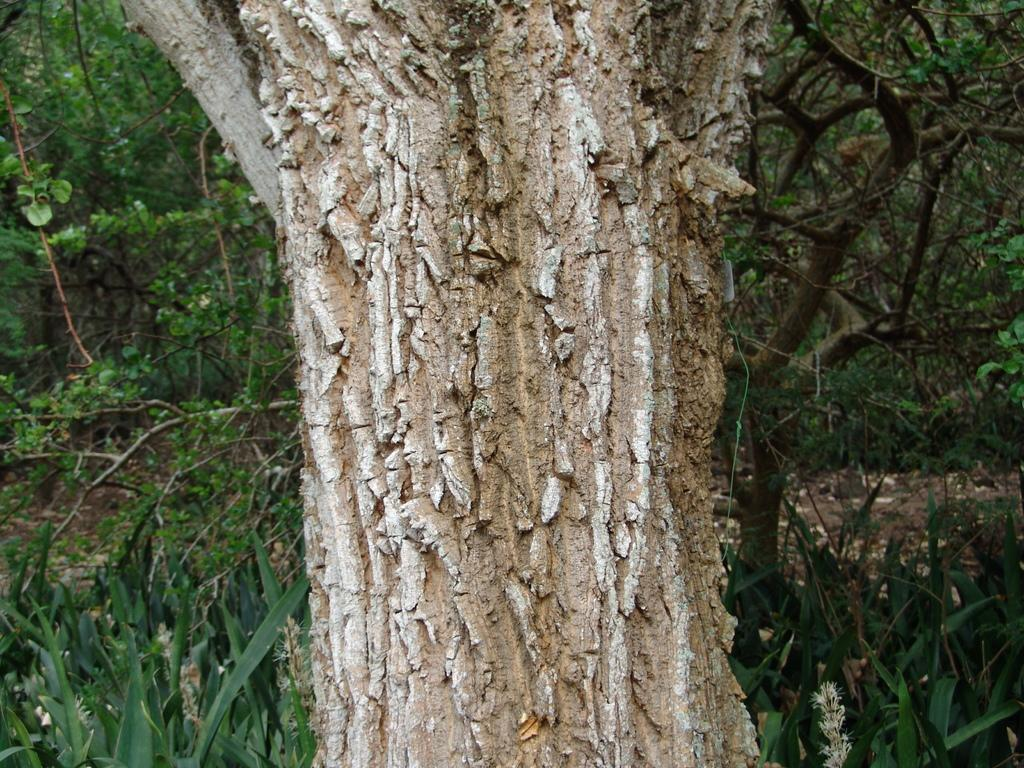What is the main object in the image? There is a branch of a tree in the image. What type of vegetation can be seen in the image? There are grass plants and trees visible in the image. Can you see any butter on the branch in the image? There is no butter present on the branch in the image. How many cats are sitting on the grass in the image? There are no cats visible in the image; it only features a branch, grass plants, and trees. 